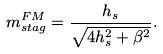<formula> <loc_0><loc_0><loc_500><loc_500>m _ { s t a g } ^ { F M } = \frac { h _ { s } } { \sqrt { 4 h _ { s } ^ { 2 } + \beta ^ { 2 } } } .</formula> 